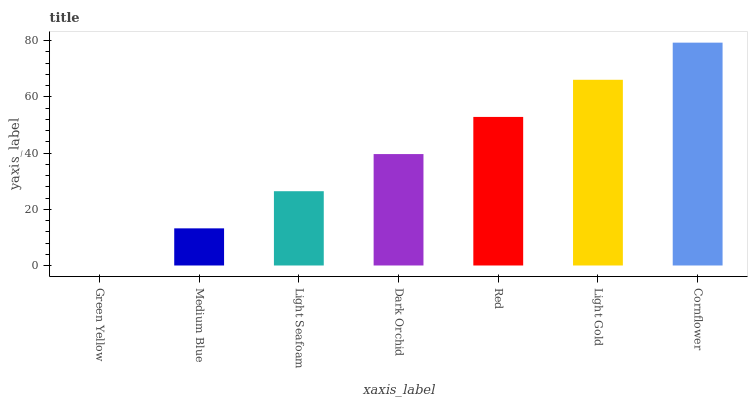Is Green Yellow the minimum?
Answer yes or no. Yes. Is Cornflower the maximum?
Answer yes or no. Yes. Is Medium Blue the minimum?
Answer yes or no. No. Is Medium Blue the maximum?
Answer yes or no. No. Is Medium Blue greater than Green Yellow?
Answer yes or no. Yes. Is Green Yellow less than Medium Blue?
Answer yes or no. Yes. Is Green Yellow greater than Medium Blue?
Answer yes or no. No. Is Medium Blue less than Green Yellow?
Answer yes or no. No. Is Dark Orchid the high median?
Answer yes or no. Yes. Is Dark Orchid the low median?
Answer yes or no. Yes. Is Cornflower the high median?
Answer yes or no. No. Is Red the low median?
Answer yes or no. No. 